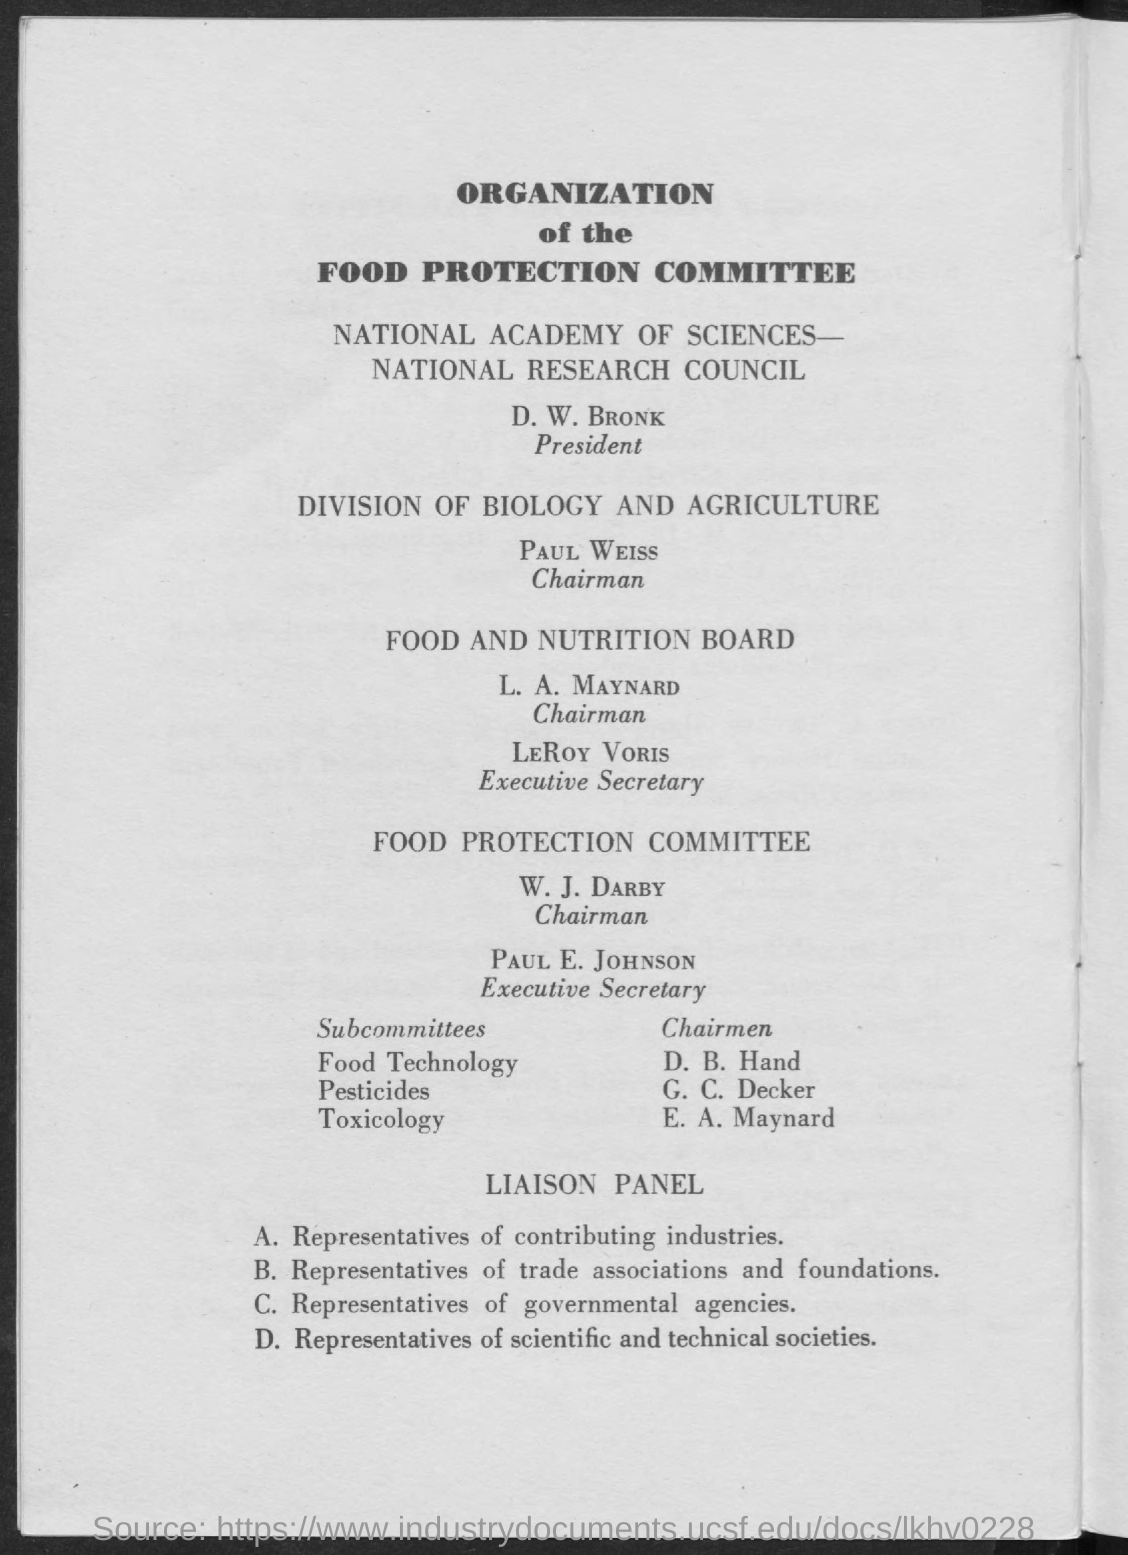Who is the president of national research council ?
Your answer should be very brief. D . W. Bronk. Who is the chairman for division of biology and agriculture ?
Your answer should be very brief. Paul Weiss. Who is the chairman of food and nutrition board ?
Offer a very short reply. L. A. Maynard. Who is the executive secretary of food and nutrition board ?
Your answer should be compact. LeRoy Voris. Who is the chairman of food projection committee ?
Offer a very short reply. W . J. Darby. Who is the executive secretary of food protection committee ?
Provide a short and direct response. Paul E. Johnson. Who is the chairman of food technology ?
Give a very brief answer. D . B. Hand. Who is the chairman of pesticides ?
Make the answer very short. G . C. Decker. Who is the chairman of toxicology ?
Provide a succinct answer. E . A. Maynard. 